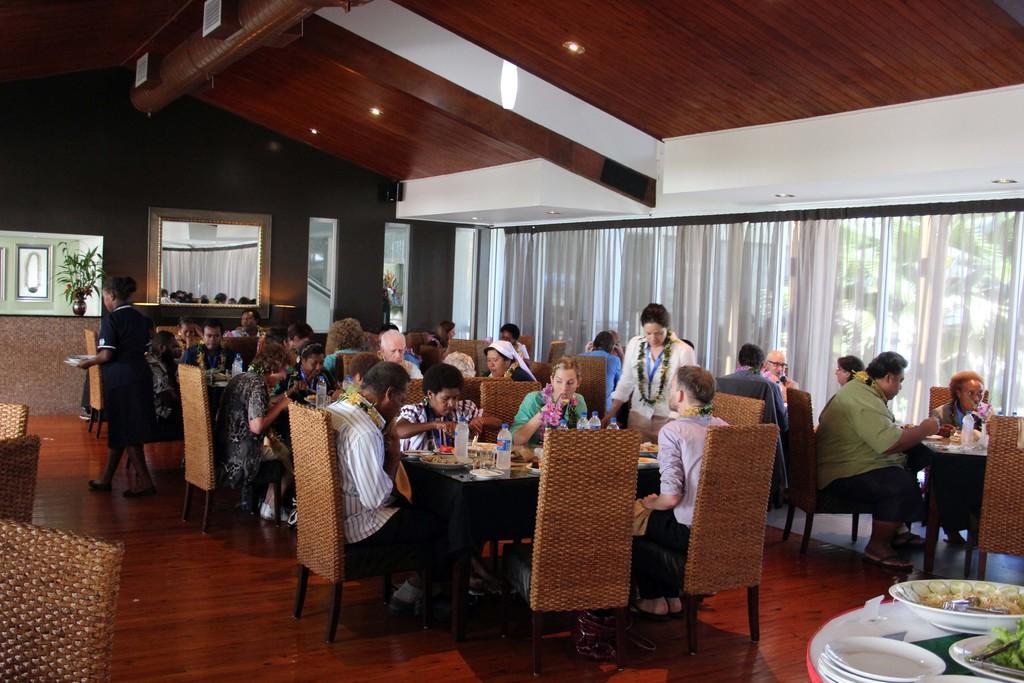In one or two sentences, can you explain what this image depicts? In this image we can see the inner view of a building and there are some people and among them few people are eating and there are some tables with food items, bottles and other objects. We can see the wall in the background with a mirror and there is a photo frame and we can see a flower vase. 